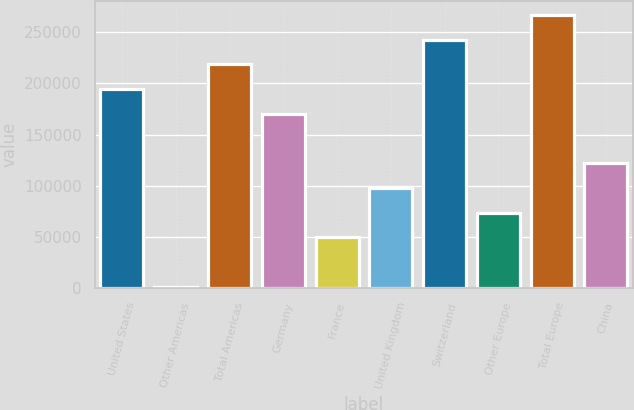Convert chart. <chart><loc_0><loc_0><loc_500><loc_500><bar_chart><fcel>United States<fcel>Other Americas<fcel>Total Americas<fcel>Germany<fcel>France<fcel>United Kingdom<fcel>Switzerland<fcel>Other Europe<fcel>Total Europe<fcel>China<nl><fcel>194407<fcel>1197<fcel>218558<fcel>170255<fcel>49499.4<fcel>97801.8<fcel>242709<fcel>73650.6<fcel>266860<fcel>121953<nl></chart> 